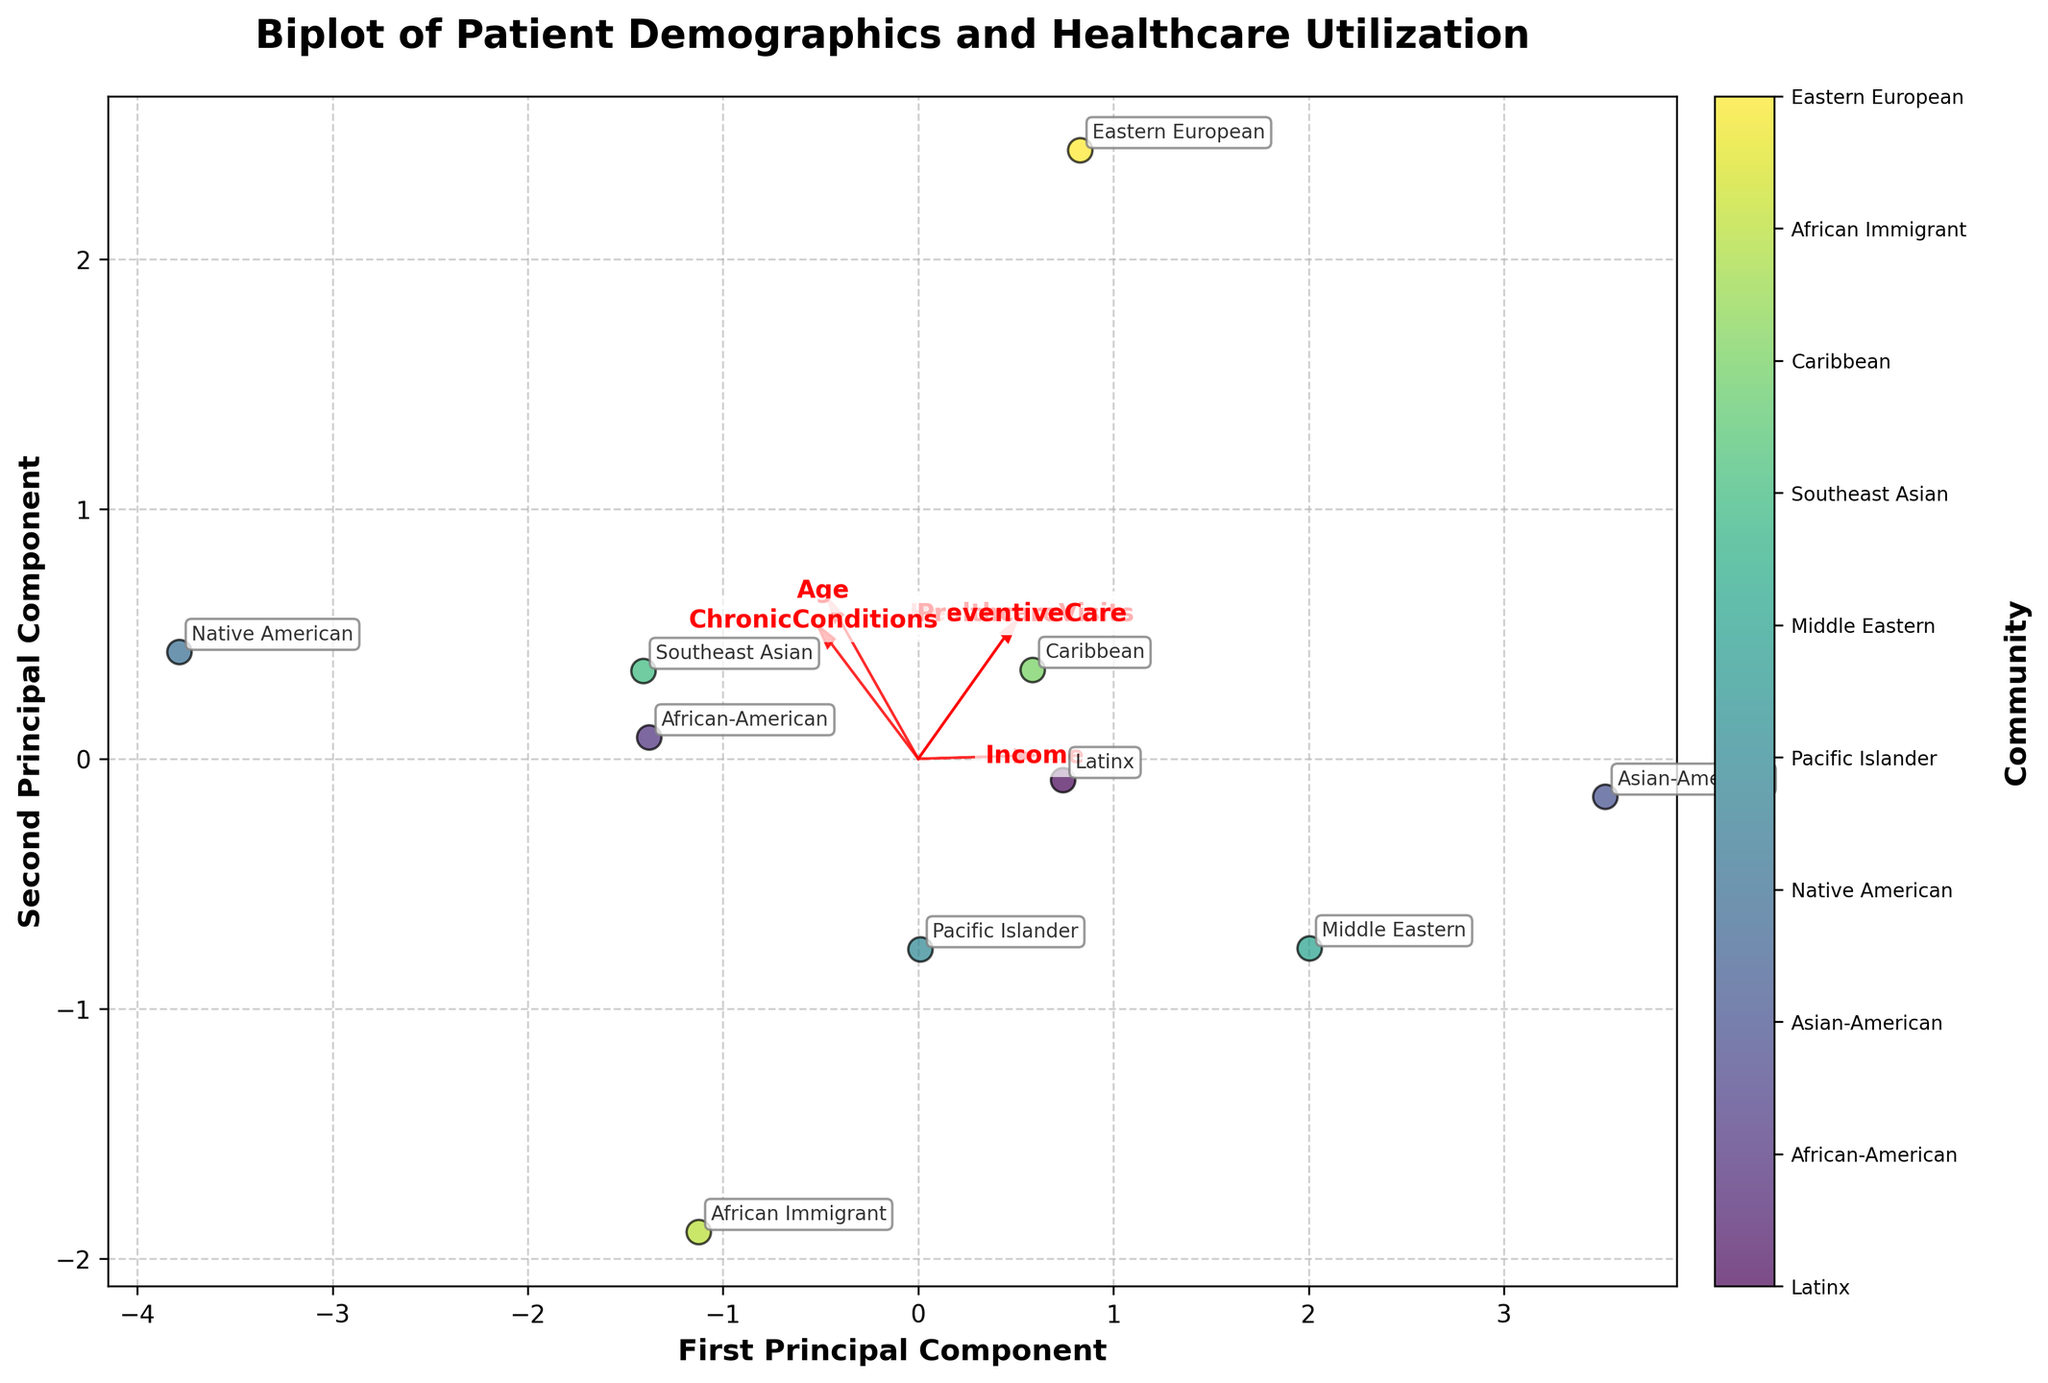What is the title of the biplot? The title of the biplot is directly shown at the top of the figure.
Answer: "Biplot of Patient Demographics and Healthcare Utilization" How many communities are represented in the biplot? By counting the number of unique communities annotated on the biplot, we can determine the total number of communities.
Answer: 10 Which community has the highest income based on the direction of the arrows? By observing which communities are plotted in the direction of the 'Income' arrow, we can determine the community with the highest income.
Answer: Asian-American What two features contribute most to the first principal component? The first principal component is represented by the x-axis. The features with arrows most aligned with this axis contribute most to it. Based on the directions, 'Income' and 'PreventiveCare' are the features most aligned.
Answer: Income, PreventiveCare Which community is associated with the highest number of chronic conditions? By looking at the arrow for 'ChronicConditions' and observing the community plotted furthest in its direction, we can determine which community has the highest number of chronic conditions.
Answer: Native American How do the features 'Age' and 'Income' visually relate to each other in the biplot? By analyzing the angles between the arrows for 'Age' and 'Income', we can see their relation. If the arrows are close to parallel, they are positively correlated; if orthogonal, they are uncorrelated; if pointing in opposite directions, they are negatively correlated. These arrows are relatively orthogonal.
Answer: Uncorrelated Which feature is least correlated with 'HealthcareVisits' based on the biplot? To identify the least correlated feature, we look for the feature whose arrow forms the largest angle with 'HealthcareVisits'. The 'Age' arrow is nearly orthogonal to 'HealthcareVisits'.
Answer: Age Compare the healthcare visits of Pacific Islander and African-American communities. By looking at the positions along the 'HealthcareVisits' direction, we can compare where each community lies. We see that the Pacific Islander and African-American communities are plotted close to each other, but the African-American community is slightly lower in the 'HealthcareVisits' direction.
Answer: African-American < Pacific Islander Is the 'PreventiveCare' feature more aligned with the first principal component (PC1) or the second principal component (PC2)? By looking at the direction of the arrow for 'PreventiveCare', we determine if it's more aligned with the horizontal axis (PC1) or the vertical axis (PC2). The 'PreventiveCare' arrow leans towards the first principal component.
Answer: PC1 How do 'ChronicConditions' and 'PreventiveCare' relate to each other? Observing the angles between the 'ChronicConditions' and 'PreventiveCare' arrows, if they are close to parallel, they are positively correlated; if orthogonal, uncorrelated; if pointing in opposite directions, negatively correlated. The arrows show a positive correlation.
Answer: Positively correlated 